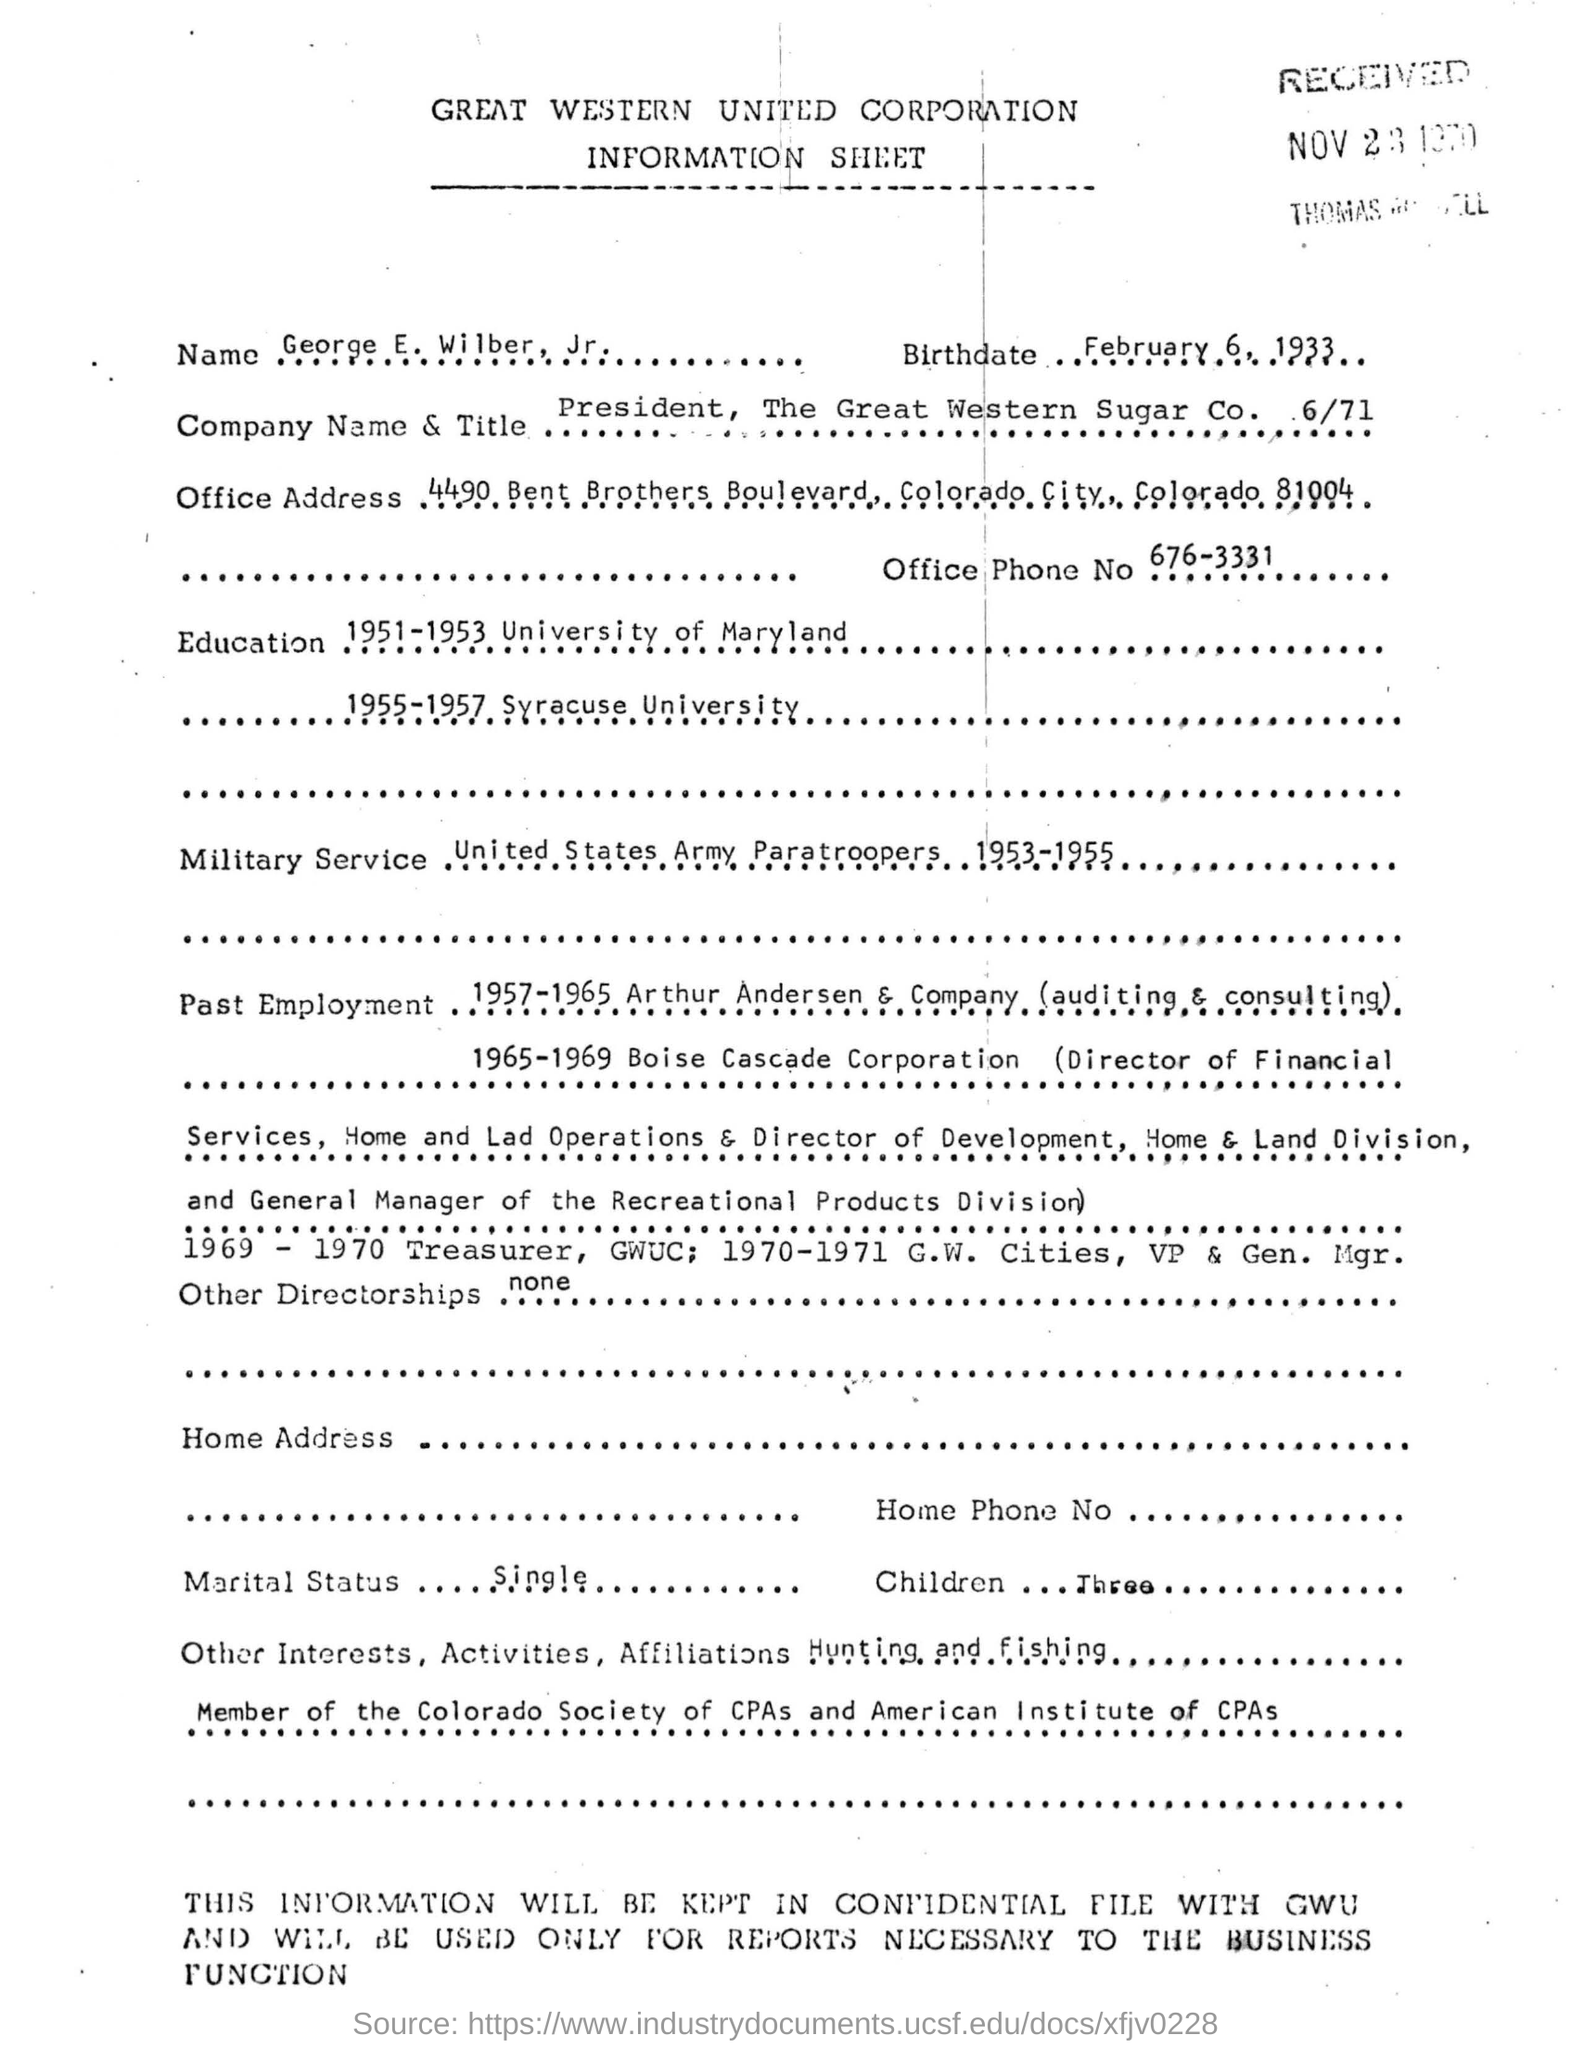List a handful of essential elements in this visual. The office phone number is 676-3331. George E Wilber Jr was born on February 6, 1933. George E Wilber Jr.'s marital status is single. George E Wilber Jr. has served in the United States Army Paratroopers. The President of The Great Western Sugar Corporation is George E Wilber Jr. 